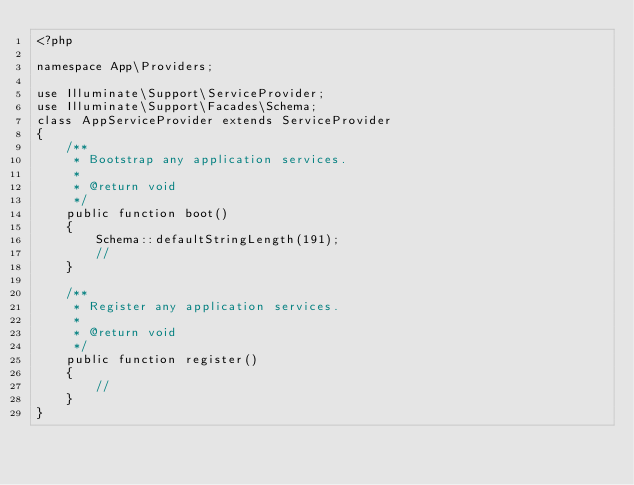<code> <loc_0><loc_0><loc_500><loc_500><_PHP_><?php

namespace App\Providers;

use Illuminate\Support\ServiceProvider;
use Illuminate\Support\Facades\Schema;
class AppServiceProvider extends ServiceProvider
{
    /**
     * Bootstrap any application services.
     *
     * @return void
     */
    public function boot()
    {
        Schema::defaultStringLength(191);
        //
    }

    /**
     * Register any application services.
     *
     * @return void
     */
    public function register()
    {
        //
    }
}
</code> 